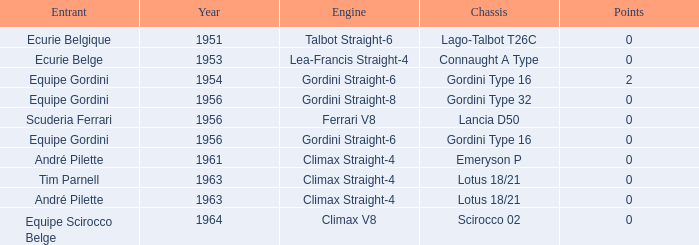Who was in 1963? Tim Parnell, André Pilette. 